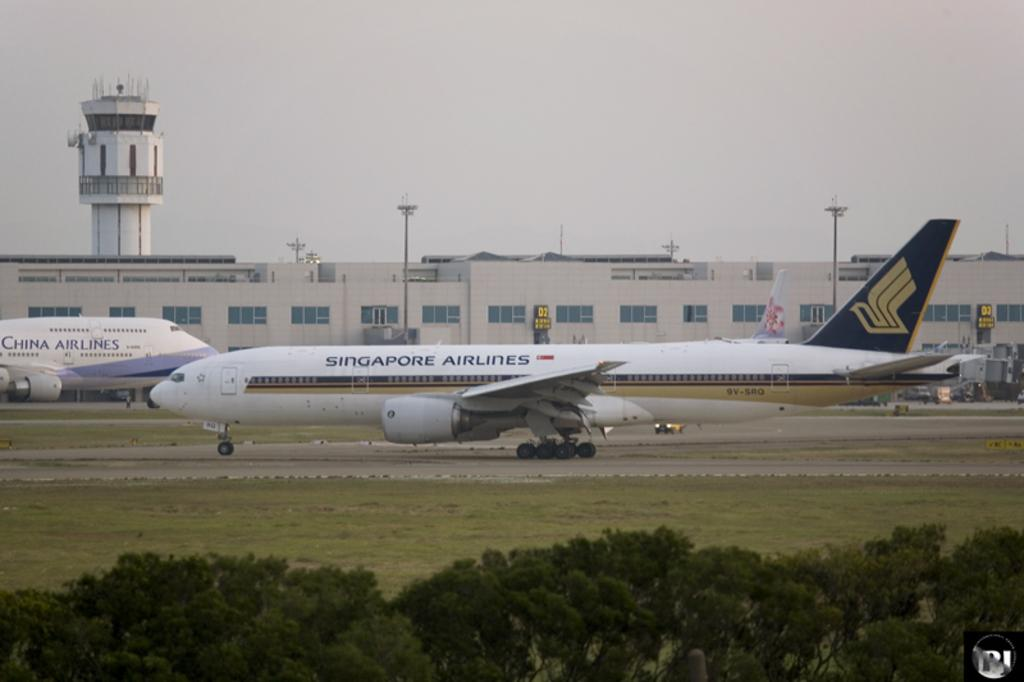<image>
Give a short and clear explanation of the subsequent image. two planes on the runway the one in front by Singapore Airlines 